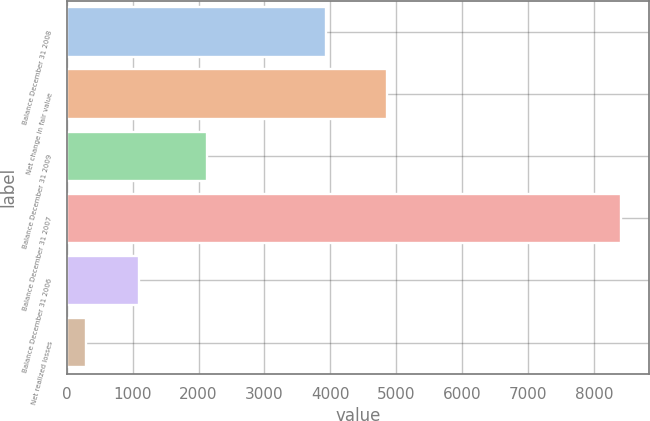Convert chart. <chart><loc_0><loc_0><loc_500><loc_500><bar_chart><fcel>Balance December 31 2008<fcel>Net change in fair value<fcel>Balance December 31 2009<fcel>Balance December 31 2007<fcel>Balance December 31 2006<fcel>Net realized losses<nl><fcel>3935<fcel>4858<fcel>2129<fcel>8416<fcel>1097.2<fcel>284<nl></chart> 